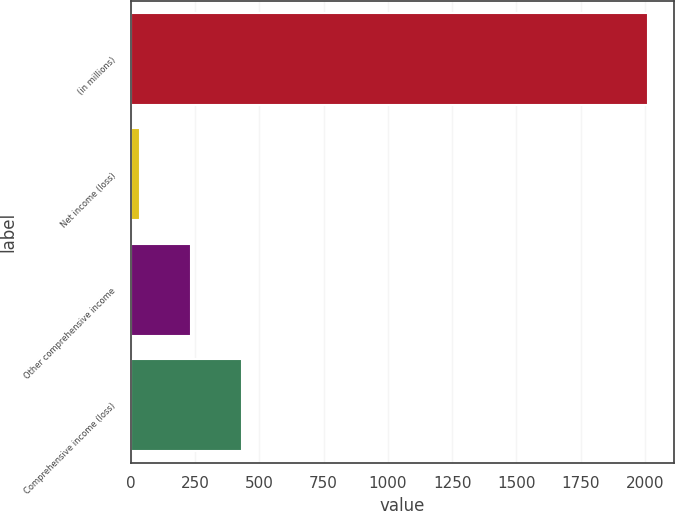<chart> <loc_0><loc_0><loc_500><loc_500><bar_chart><fcel>(in millions)<fcel>Net income (loss)<fcel>Other comprehensive income<fcel>Comprehensive income (loss)<nl><fcel>2011<fcel>37<fcel>234.4<fcel>431.8<nl></chart> 